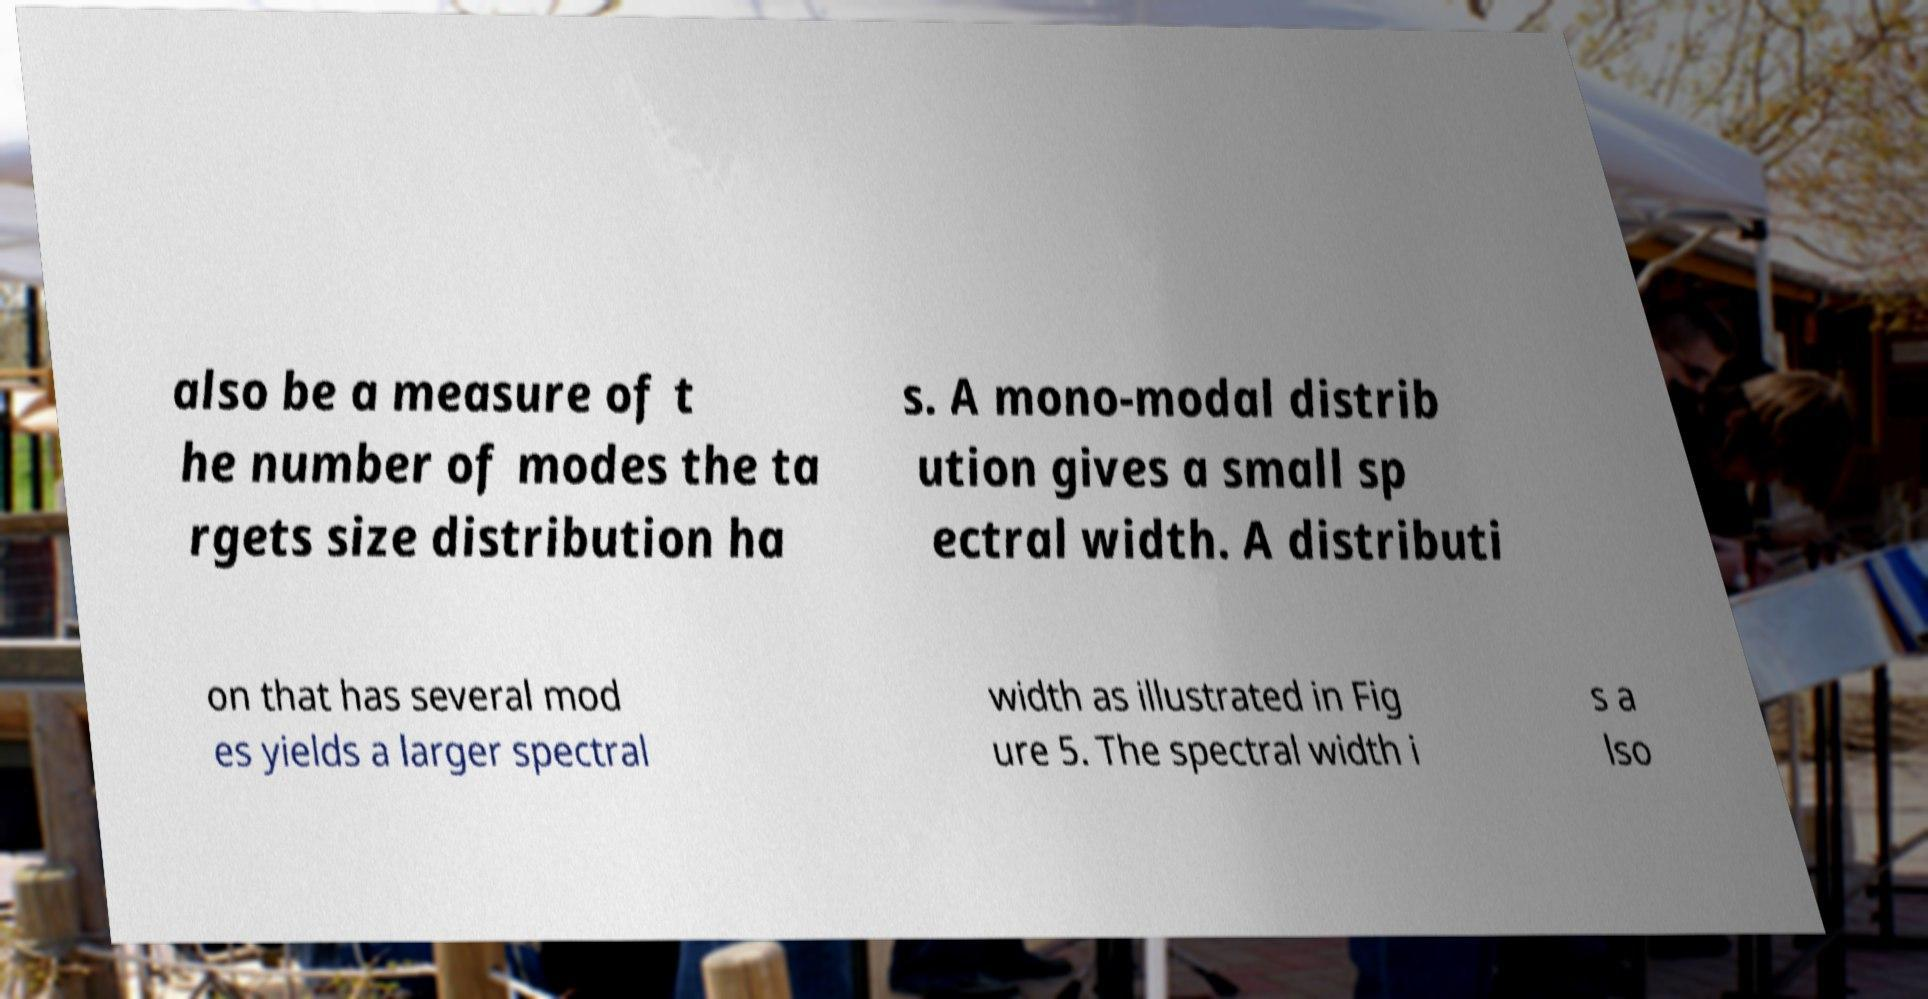Could you assist in decoding the text presented in this image and type it out clearly? also be a measure of t he number of modes the ta rgets size distribution ha s. A mono-modal distrib ution gives a small sp ectral width. A distributi on that has several mod es yields a larger spectral width as illustrated in Fig ure 5. The spectral width i s a lso 